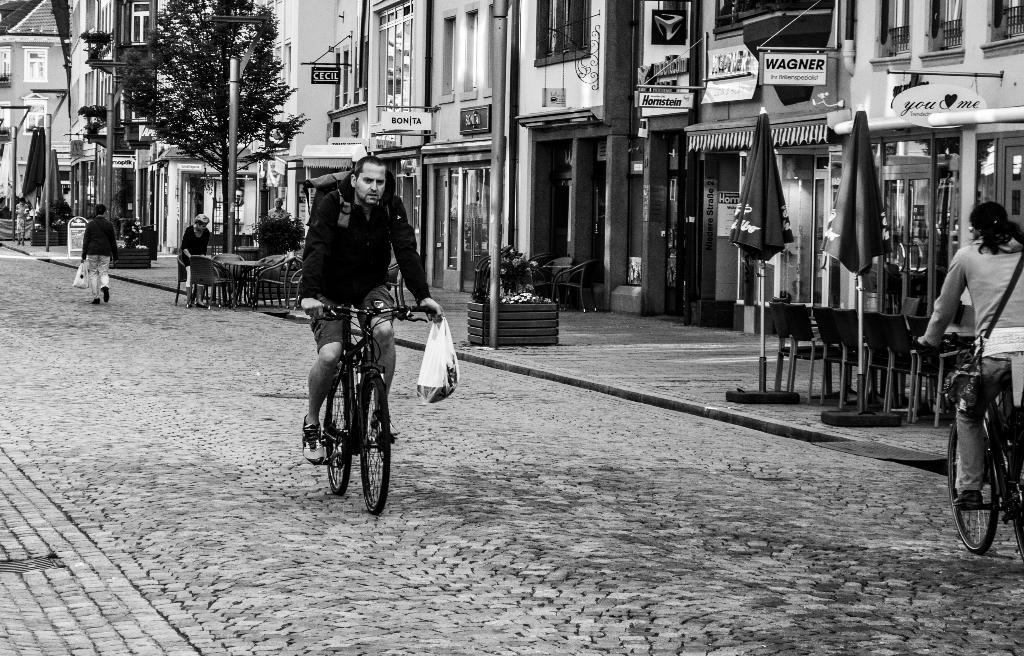What is the man in the image doing? There is a man riding a bicycle in the image. What type of structures can be seen in the background? There are buildings in the image. Where does the scene appear to be taking place? The scene appears to be on a street. What type of establishments can be seen in the image? There are some stores and hotels in the image. Where is the cannon located in the image? There is no cannon present in the image. What is the cent of the image? The term "cent" is not relevant to describing the image, as it refers to a unit of currency or a small unit of measurement. The image features a man riding a bicycle, buildings, a street setting, and stores and hotels. 